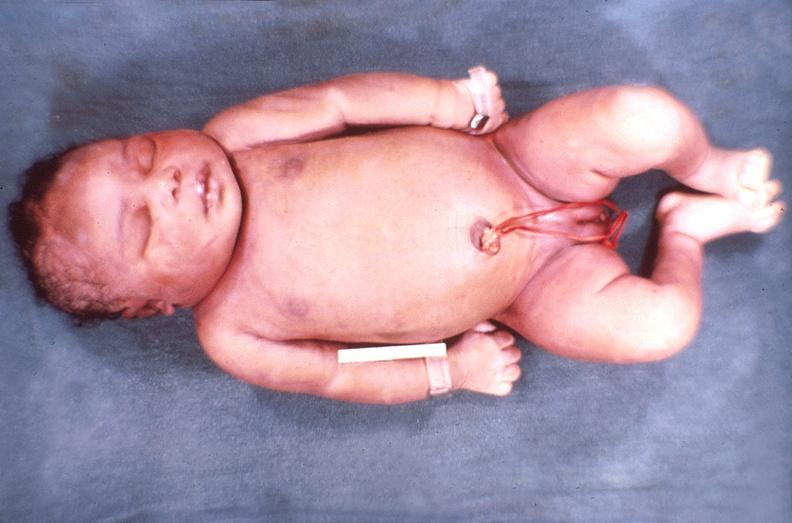does newborn cord around neck show hemolytic disease of newborn?
Answer the question using a single word or phrase. No 